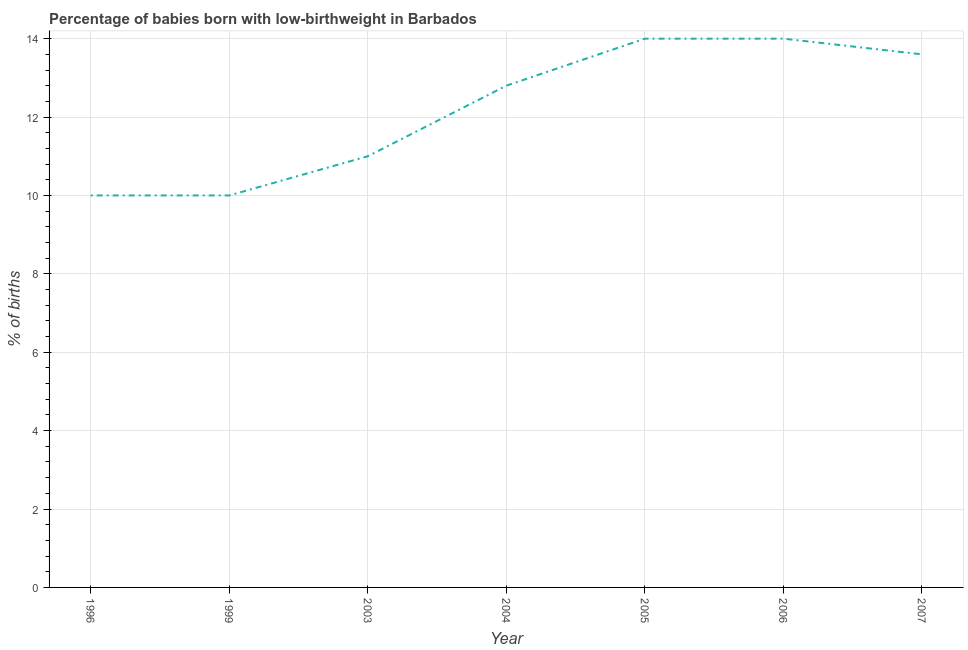Across all years, what is the minimum percentage of babies who were born with low-birthweight?
Your answer should be very brief. 10. In which year was the percentage of babies who were born with low-birthweight maximum?
Make the answer very short. 2005. What is the sum of the percentage of babies who were born with low-birthweight?
Offer a very short reply. 85.4. What is the difference between the percentage of babies who were born with low-birthweight in 2006 and 2007?
Provide a succinct answer. 0.4. What is the average percentage of babies who were born with low-birthweight per year?
Provide a succinct answer. 12.2. What is the median percentage of babies who were born with low-birthweight?
Keep it short and to the point. 12.8. In how many years, is the percentage of babies who were born with low-birthweight greater than 10 %?
Your answer should be compact. 5. What is the ratio of the percentage of babies who were born with low-birthweight in 1999 to that in 2006?
Your answer should be compact. 0.71. Is the sum of the percentage of babies who were born with low-birthweight in 2004 and 2006 greater than the maximum percentage of babies who were born with low-birthweight across all years?
Provide a succinct answer. Yes. What is the difference between the highest and the lowest percentage of babies who were born with low-birthweight?
Your response must be concise. 4. How many lines are there?
Provide a succinct answer. 1. How many years are there in the graph?
Your response must be concise. 7. Does the graph contain any zero values?
Keep it short and to the point. No. What is the title of the graph?
Ensure brevity in your answer.  Percentage of babies born with low-birthweight in Barbados. What is the label or title of the X-axis?
Your answer should be very brief. Year. What is the label or title of the Y-axis?
Offer a very short reply. % of births. What is the % of births of 1996?
Give a very brief answer. 10. What is the % of births of 1999?
Provide a short and direct response. 10. What is the % of births of 2003?
Ensure brevity in your answer.  11. What is the % of births in 2004?
Keep it short and to the point. 12.8. What is the % of births of 2006?
Offer a terse response. 14. What is the difference between the % of births in 1996 and 2003?
Give a very brief answer. -1. What is the difference between the % of births in 1996 and 2004?
Offer a very short reply. -2.8. What is the difference between the % of births in 1996 and 2005?
Ensure brevity in your answer.  -4. What is the difference between the % of births in 1996 and 2007?
Provide a succinct answer. -3.6. What is the difference between the % of births in 1999 and 2003?
Offer a terse response. -1. What is the difference between the % of births in 1999 and 2004?
Your answer should be very brief. -2.8. What is the difference between the % of births in 1999 and 2005?
Provide a short and direct response. -4. What is the difference between the % of births in 1999 and 2006?
Give a very brief answer. -4. What is the difference between the % of births in 1999 and 2007?
Keep it short and to the point. -3.6. What is the difference between the % of births in 2003 and 2004?
Offer a terse response. -1.8. What is the difference between the % of births in 2003 and 2005?
Offer a terse response. -3. What is the difference between the % of births in 2003 and 2007?
Offer a terse response. -2.6. What is the difference between the % of births in 2004 and 2005?
Provide a succinct answer. -1.2. What is the difference between the % of births in 2004 and 2006?
Ensure brevity in your answer.  -1.2. What is the difference between the % of births in 2005 and 2006?
Keep it short and to the point. 0. What is the difference between the % of births in 2006 and 2007?
Provide a short and direct response. 0.4. What is the ratio of the % of births in 1996 to that in 1999?
Offer a very short reply. 1. What is the ratio of the % of births in 1996 to that in 2003?
Ensure brevity in your answer.  0.91. What is the ratio of the % of births in 1996 to that in 2004?
Your answer should be compact. 0.78. What is the ratio of the % of births in 1996 to that in 2005?
Make the answer very short. 0.71. What is the ratio of the % of births in 1996 to that in 2006?
Offer a terse response. 0.71. What is the ratio of the % of births in 1996 to that in 2007?
Your answer should be compact. 0.73. What is the ratio of the % of births in 1999 to that in 2003?
Your answer should be compact. 0.91. What is the ratio of the % of births in 1999 to that in 2004?
Offer a terse response. 0.78. What is the ratio of the % of births in 1999 to that in 2005?
Your answer should be very brief. 0.71. What is the ratio of the % of births in 1999 to that in 2006?
Make the answer very short. 0.71. What is the ratio of the % of births in 1999 to that in 2007?
Offer a very short reply. 0.73. What is the ratio of the % of births in 2003 to that in 2004?
Your response must be concise. 0.86. What is the ratio of the % of births in 2003 to that in 2005?
Ensure brevity in your answer.  0.79. What is the ratio of the % of births in 2003 to that in 2006?
Offer a very short reply. 0.79. What is the ratio of the % of births in 2003 to that in 2007?
Provide a short and direct response. 0.81. What is the ratio of the % of births in 2004 to that in 2005?
Your answer should be very brief. 0.91. What is the ratio of the % of births in 2004 to that in 2006?
Provide a short and direct response. 0.91. What is the ratio of the % of births in 2004 to that in 2007?
Keep it short and to the point. 0.94. What is the ratio of the % of births in 2005 to that in 2006?
Your answer should be very brief. 1. What is the ratio of the % of births in 2005 to that in 2007?
Offer a terse response. 1.03. What is the ratio of the % of births in 2006 to that in 2007?
Give a very brief answer. 1.03. 